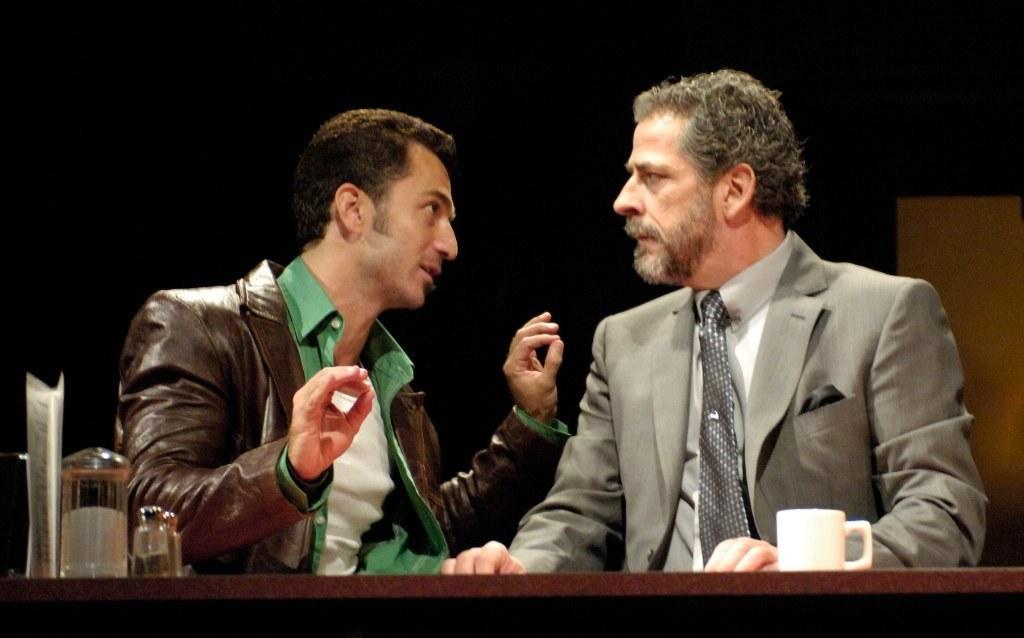Can you describe this image briefly? In the foreground of this picture we can see a table on the top of which a cup, bottles and some objects are placed and we can see a man wearing a suit and seems to be sitting and we can see a person wearing jacket, sitting and seems to be talking. The background of the image is dark and we can see an object in the background. 